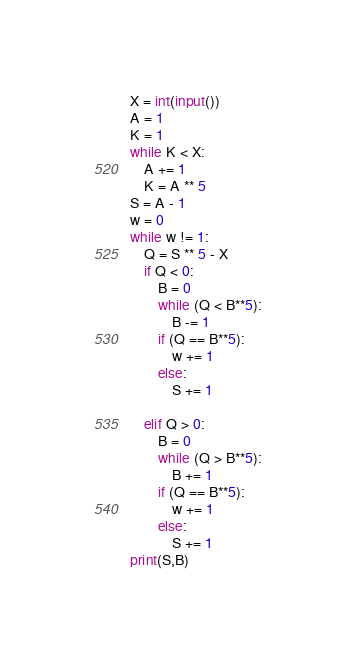Convert code to text. <code><loc_0><loc_0><loc_500><loc_500><_Python_>X = int(input())
A = 1
K = 1
while K < X:
    A += 1
    K = A ** 5
S = A - 1
w = 0
while w != 1:
    Q = S ** 5 - X
    if Q < 0:
        B = 0
        while (Q < B**5):
            B -= 1
        if (Q == B**5):
            w += 1
        else:
            S += 1
        
    elif Q > 0:
        B = 0
        while (Q > B**5):
            B += 1
        if (Q == B**5):
            w += 1
        else:
            S += 1
print(S,B)</code> 